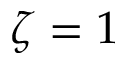Convert formula to latex. <formula><loc_0><loc_0><loc_500><loc_500>\zeta = 1</formula> 